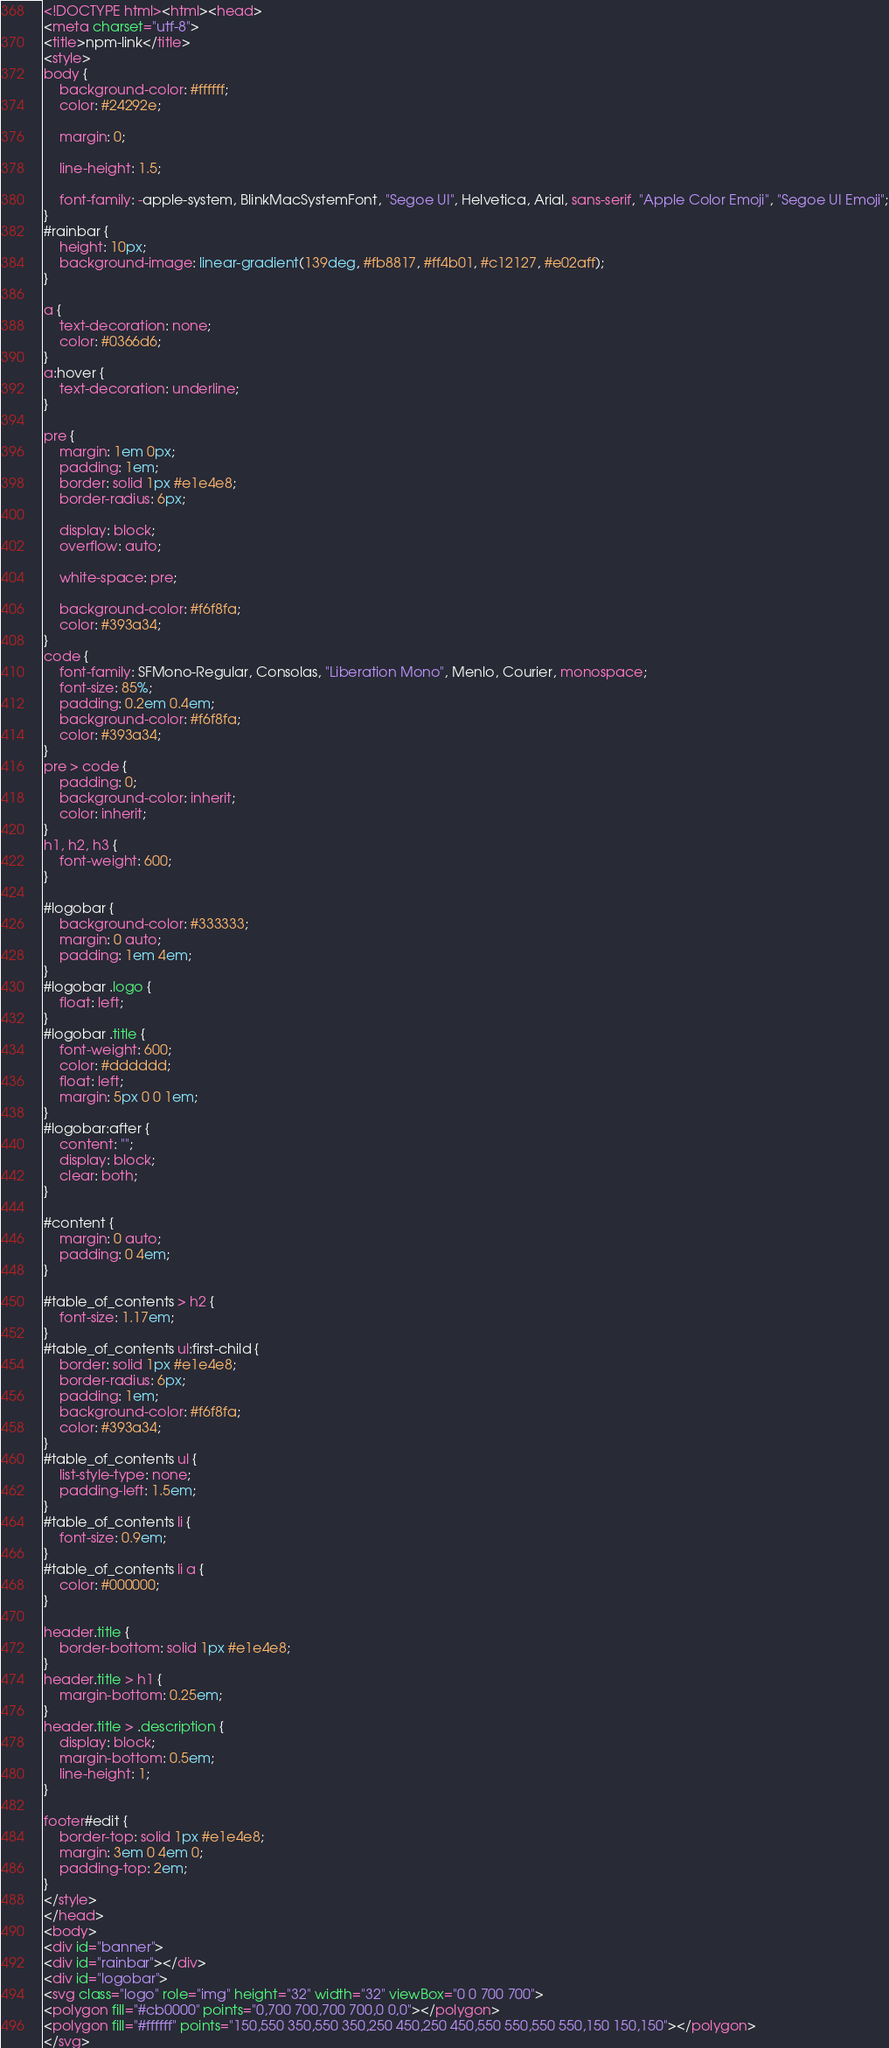<code> <loc_0><loc_0><loc_500><loc_500><_HTML_><!DOCTYPE html><html><head>
<meta charset="utf-8">
<title>npm-link</title>
<style>
body {
    background-color: #ffffff;
    color: #24292e;

    margin: 0;

    line-height: 1.5;

    font-family: -apple-system, BlinkMacSystemFont, "Segoe UI", Helvetica, Arial, sans-serif, "Apple Color Emoji", "Segoe UI Emoji";
}
#rainbar {
    height: 10px;
    background-image: linear-gradient(139deg, #fb8817, #ff4b01, #c12127, #e02aff);
}

a {
    text-decoration: none;
    color: #0366d6;
}
a:hover {
    text-decoration: underline;
}

pre {
    margin: 1em 0px;
    padding: 1em;
    border: solid 1px #e1e4e8;
    border-radius: 6px;

    display: block;
    overflow: auto;

    white-space: pre;

    background-color: #f6f8fa;
    color: #393a34;
}
code {
    font-family: SFMono-Regular, Consolas, "Liberation Mono", Menlo, Courier, monospace;
    font-size: 85%;
    padding: 0.2em 0.4em;
    background-color: #f6f8fa;
    color: #393a34;
}
pre > code {
    padding: 0;
    background-color: inherit;
    color: inherit;
}
h1, h2, h3 {
    font-weight: 600;
}

#logobar {
    background-color: #333333;
    margin: 0 auto;
    padding: 1em 4em;
}
#logobar .logo {
    float: left;
}
#logobar .title {
    font-weight: 600;
    color: #dddddd;
    float: left;
    margin: 5px 0 0 1em;
}
#logobar:after {
    content: "";
    display: block;
    clear: both;
}

#content {
    margin: 0 auto;
    padding: 0 4em;
}

#table_of_contents > h2 {
    font-size: 1.17em;
}
#table_of_contents ul:first-child {
    border: solid 1px #e1e4e8;
    border-radius: 6px;
    padding: 1em;
    background-color: #f6f8fa;
    color: #393a34;
}
#table_of_contents ul {
    list-style-type: none;
    padding-left: 1.5em;
}
#table_of_contents li {
    font-size: 0.9em;
}
#table_of_contents li a {
    color: #000000;
}

header.title {
    border-bottom: solid 1px #e1e4e8;
}
header.title > h1 {
    margin-bottom: 0.25em;
}
header.title > .description {
    display: block;
    margin-bottom: 0.5em;
    line-height: 1;
}

footer#edit {
    border-top: solid 1px #e1e4e8;
    margin: 3em 0 4em 0;
    padding-top: 2em;
}
</style>
</head>
<body>
<div id="banner">
<div id="rainbar"></div>
<div id="logobar">
<svg class="logo" role="img" height="32" width="32" viewBox="0 0 700 700">
<polygon fill="#cb0000" points="0,700 700,700 700,0 0,0"></polygon>
<polygon fill="#ffffff" points="150,550 350,550 350,250 450,250 450,550 550,550 550,150 150,150"></polygon>
</svg></code> 